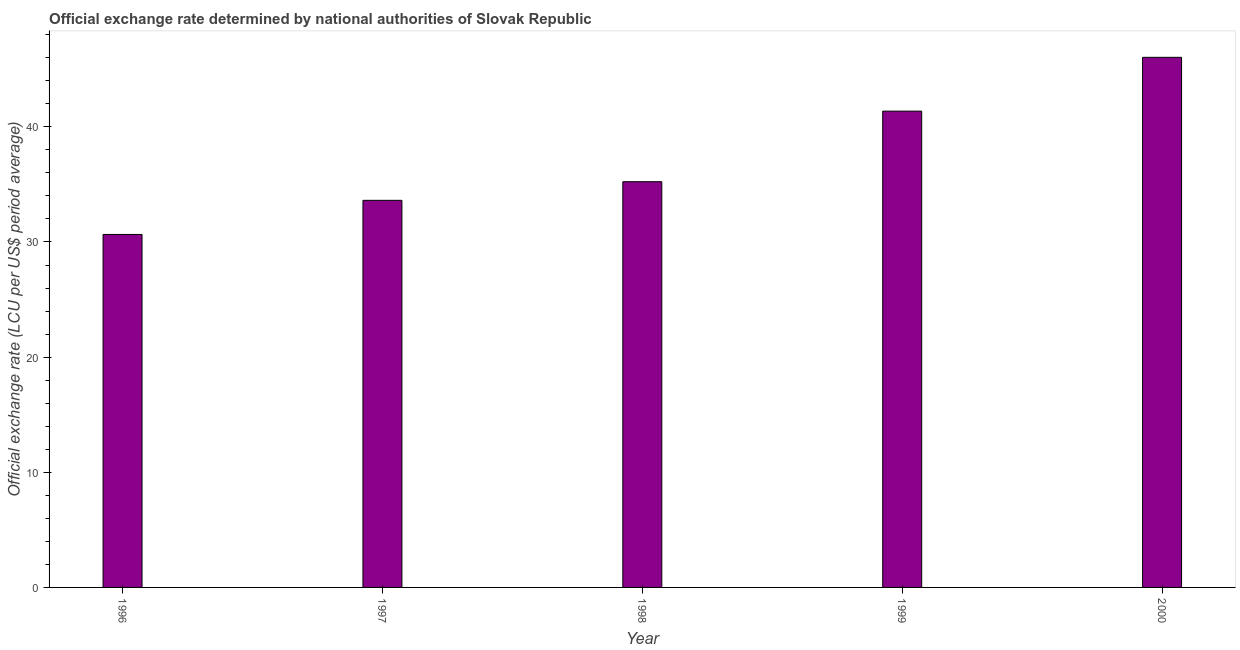Does the graph contain any zero values?
Your answer should be very brief. No. Does the graph contain grids?
Your answer should be very brief. No. What is the title of the graph?
Offer a terse response. Official exchange rate determined by national authorities of Slovak Republic. What is the label or title of the X-axis?
Ensure brevity in your answer.  Year. What is the label or title of the Y-axis?
Keep it short and to the point. Official exchange rate (LCU per US$ period average). What is the official exchange rate in 1996?
Give a very brief answer. 30.65. Across all years, what is the maximum official exchange rate?
Give a very brief answer. 46.04. Across all years, what is the minimum official exchange rate?
Give a very brief answer. 30.65. In which year was the official exchange rate maximum?
Give a very brief answer. 2000. What is the sum of the official exchange rate?
Your response must be concise. 186.9. What is the difference between the official exchange rate in 1997 and 2000?
Ensure brevity in your answer.  -12.42. What is the average official exchange rate per year?
Give a very brief answer. 37.38. What is the median official exchange rate?
Offer a very short reply. 35.23. What is the ratio of the official exchange rate in 1996 to that in 1998?
Ensure brevity in your answer.  0.87. Is the official exchange rate in 1997 less than that in 2000?
Keep it short and to the point. Yes. What is the difference between the highest and the second highest official exchange rate?
Provide a short and direct response. 4.67. What is the difference between the highest and the lowest official exchange rate?
Offer a terse response. 15.38. Are all the bars in the graph horizontal?
Provide a succinct answer. No. What is the Official exchange rate (LCU per US$ period average) of 1996?
Provide a succinct answer. 30.65. What is the Official exchange rate (LCU per US$ period average) of 1997?
Provide a succinct answer. 33.62. What is the Official exchange rate (LCU per US$ period average) in 1998?
Offer a very short reply. 35.23. What is the Official exchange rate (LCU per US$ period average) of 1999?
Your answer should be very brief. 41.36. What is the Official exchange rate (LCU per US$ period average) of 2000?
Provide a short and direct response. 46.04. What is the difference between the Official exchange rate (LCU per US$ period average) in 1996 and 1997?
Ensure brevity in your answer.  -2.96. What is the difference between the Official exchange rate (LCU per US$ period average) in 1996 and 1998?
Your answer should be very brief. -4.58. What is the difference between the Official exchange rate (LCU per US$ period average) in 1996 and 1999?
Ensure brevity in your answer.  -10.71. What is the difference between the Official exchange rate (LCU per US$ period average) in 1996 and 2000?
Your answer should be very brief. -15.38. What is the difference between the Official exchange rate (LCU per US$ period average) in 1997 and 1998?
Provide a short and direct response. -1.62. What is the difference between the Official exchange rate (LCU per US$ period average) in 1997 and 1999?
Give a very brief answer. -7.75. What is the difference between the Official exchange rate (LCU per US$ period average) in 1997 and 2000?
Your answer should be compact. -12.42. What is the difference between the Official exchange rate (LCU per US$ period average) in 1998 and 1999?
Give a very brief answer. -6.13. What is the difference between the Official exchange rate (LCU per US$ period average) in 1998 and 2000?
Provide a succinct answer. -10.8. What is the difference between the Official exchange rate (LCU per US$ period average) in 1999 and 2000?
Give a very brief answer. -4.67. What is the ratio of the Official exchange rate (LCU per US$ period average) in 1996 to that in 1997?
Ensure brevity in your answer.  0.91. What is the ratio of the Official exchange rate (LCU per US$ period average) in 1996 to that in 1998?
Offer a terse response. 0.87. What is the ratio of the Official exchange rate (LCU per US$ period average) in 1996 to that in 1999?
Provide a succinct answer. 0.74. What is the ratio of the Official exchange rate (LCU per US$ period average) in 1996 to that in 2000?
Provide a succinct answer. 0.67. What is the ratio of the Official exchange rate (LCU per US$ period average) in 1997 to that in 1998?
Your answer should be compact. 0.95. What is the ratio of the Official exchange rate (LCU per US$ period average) in 1997 to that in 1999?
Keep it short and to the point. 0.81. What is the ratio of the Official exchange rate (LCU per US$ period average) in 1997 to that in 2000?
Ensure brevity in your answer.  0.73. What is the ratio of the Official exchange rate (LCU per US$ period average) in 1998 to that in 1999?
Provide a succinct answer. 0.85. What is the ratio of the Official exchange rate (LCU per US$ period average) in 1998 to that in 2000?
Provide a succinct answer. 0.77. What is the ratio of the Official exchange rate (LCU per US$ period average) in 1999 to that in 2000?
Make the answer very short. 0.9. 